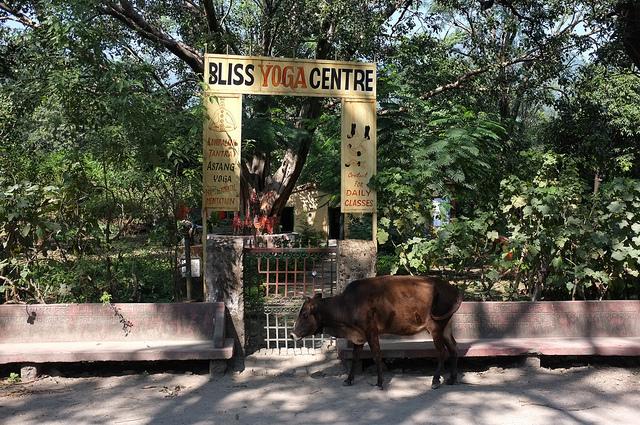What type of animal is pictured?
Concise answer only. Cow. How many shadows are on the ground?
Be succinct. 5. What type of activity takes place at this center?
Concise answer only. Yoga. 